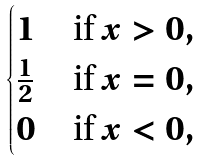Convert formula to latex. <formula><loc_0><loc_0><loc_500><loc_500>\begin{cases} 1 & \text {if $x>0$} , \\ \frac { 1 } { 2 } & \text {if $x=0$} , \\ 0 & \text {if $x<0$} , \end{cases}</formula> 